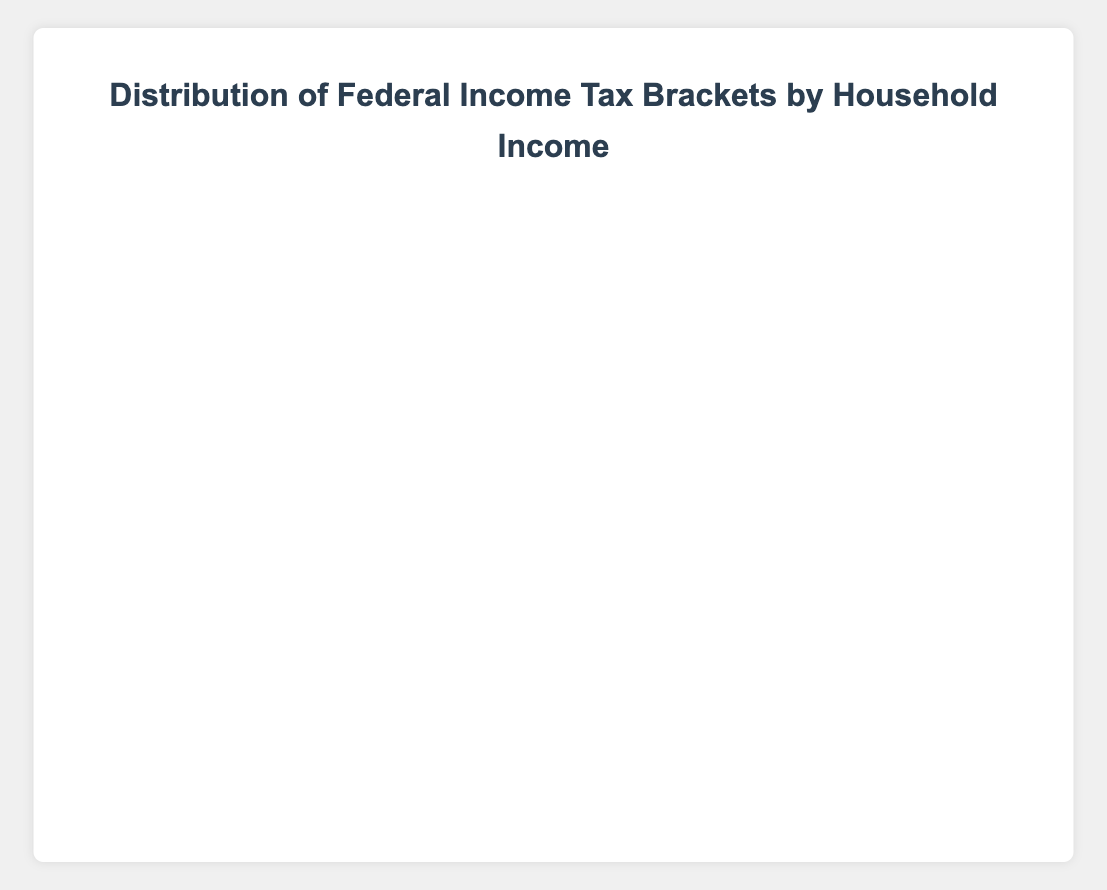How many households in total fall under the "12%" federal income tax bracket? Sum the number of households in the "12%" tax bracket across all income levels. The values are 0 (Below $20K) + 150 ($20K-$40K) + 200 ($40K-$60K) + 150 ($60K-$80K) + 100 ($80K-$100K) + 0 ($100K-$150K) + 0 ($150K-$200K) + 0 (Above $200K) = 600.
Answer: 600 Which household income bracket has the highest number of "No Tax" households? Compare the count of "No Tax" households for each income bracket. "Below $20,000" has 80, "$20,000 - $40,000" has 50, "$40,000 - $60,000" has 25, "$60,000 - $80,000" has 0, "$80,000 - $100,000" has 0, "$100,000 - $150,000" has 0, "$150,000 - $200,000" has 0, "Above $200,000" has 0.
Answer: Below $20,000 What is the total number of households in the "$60,000 - $80,000" income bracket? Sum the number of households across all tax brackets for the "$60,000 - $80,000" income bracket. The values are 50 (10%) + 150 (12%) + 200 (22%) + 100 (24%) + 0 (32%) + 0 (35%) + 0 (37%) + 0 (No Tax) = 500.
Answer: 500 In which tax bracket does the "$40,000 - $60,000" income bracket have the highest number of households? Look at the number of households for each tax bracket within the "$40,000 - $60,000" income bracket. "10%" has 150, "12%" has 200, "22%" has 100, "24%" has 0, "32%" has 0, "35%" has 0, "37%" has 0, "No Tax" has 25. The highest is the "12%" bracket.
Answer: 12% How many more households in the "$80,000 - $100,000" income bracket are in the 24% tax bracket compared to the 10% tax bracket? Find the difference in the number of households between the 24% and 10% tax brackets for the "$80,000 - $100,000" income bracket. The values are 200 (24%) - 0 (10%) = 200.
Answer: 200 Is the number of households in the 35% tax bracket greater than in the 32% tax bracket for the "Above $200,000" income bracket? Compare the number of households for the 35% and 32% tax brackets in the "Above $200,000" income bracket. The values are 200 (35%) and 100 (32%). 200 is greater than 100.
Answer: Yes Which income bracket has the largest proportion of households in the "10%" tax bracket? Look at the proportion of households in the "10%" tax bracket across all income levels. Calculate proportion as (households in 10% bracket/total households) for each income bracket. For "Below $20,000": 100/(100+80) = 0.556. For "$20,000 - $40,000": 200/(200+150+50) = 0.471. For "$40,000 - $60,000": 150/(150+200+100+25) = 0.273. For "$60,000 - $80,000": 50/(50+150+200+100) = 0.10. For "$80,000 - $100,000": 0. For "$100,000 - $150,000": 0. For "$150,000 - $200,000": 0. For "Above $200,000": 0. The largest proportion is 0.556 for "Below $20,000".
Answer: Below $20,000 